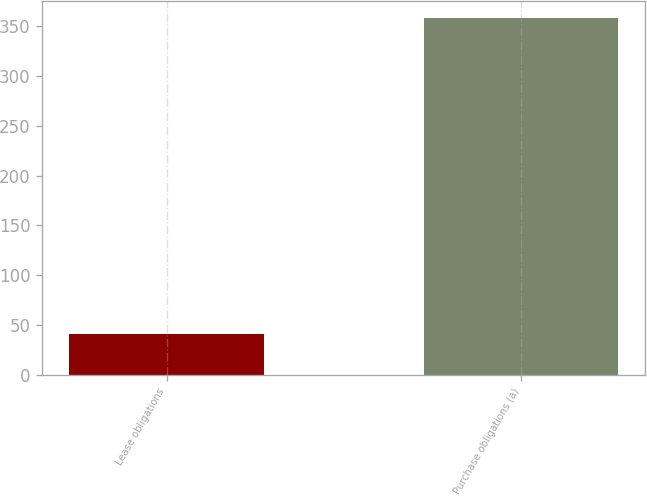Convert chart to OTSL. <chart><loc_0><loc_0><loc_500><loc_500><bar_chart><fcel>Lease obligations<fcel>Purchase obligations (a)<nl><fcel>41<fcel>358<nl></chart> 